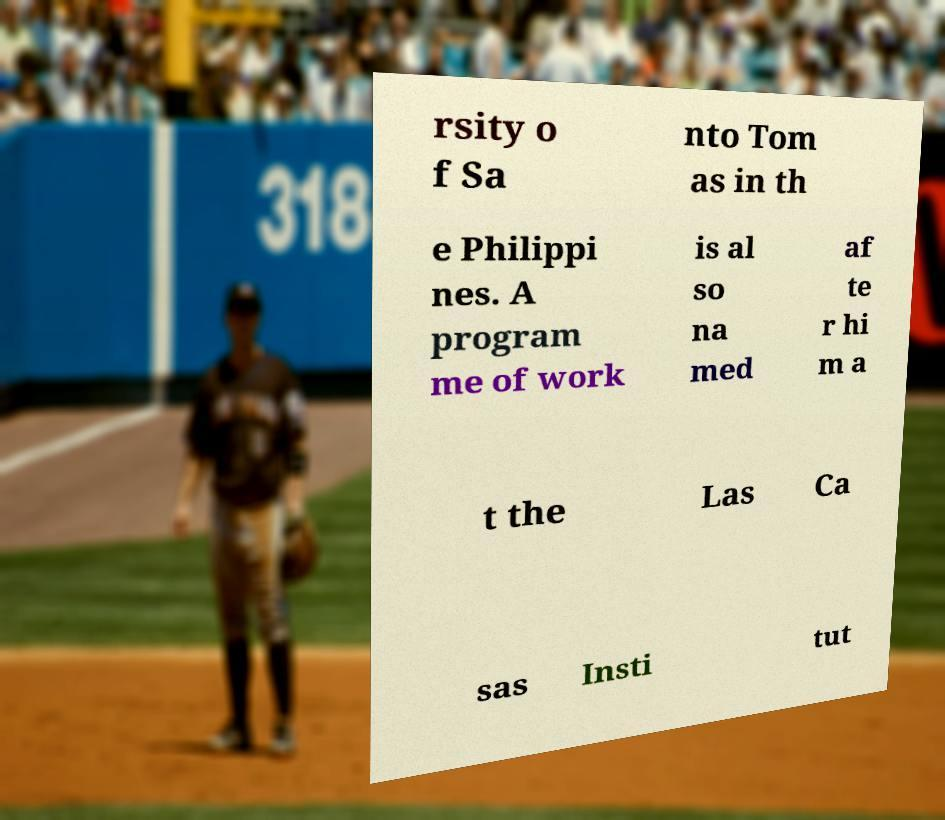Could you extract and type out the text from this image? rsity o f Sa nto Tom as in th e Philippi nes. A program me of work is al so na med af te r hi m a t the Las Ca sas Insti tut 